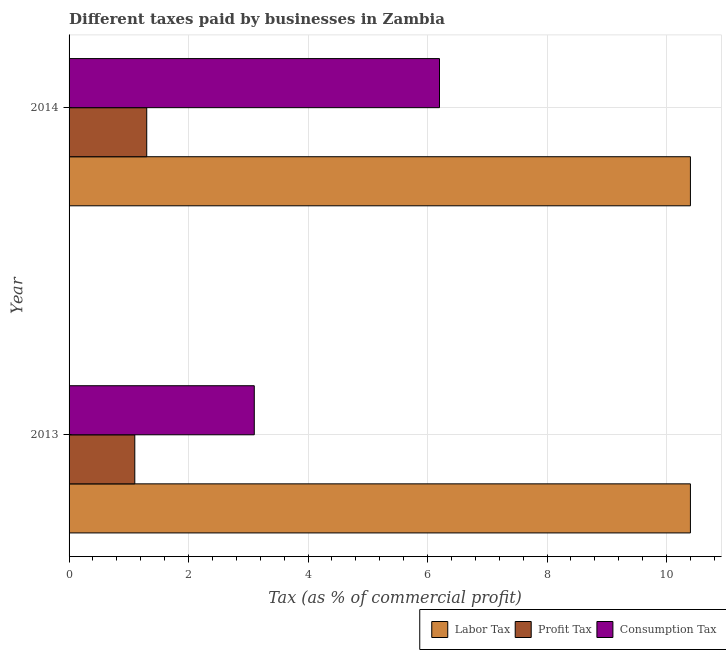How many groups of bars are there?
Offer a very short reply. 2. How many bars are there on the 2nd tick from the bottom?
Provide a succinct answer. 3. What is the label of the 1st group of bars from the top?
Provide a succinct answer. 2014. In how many cases, is the number of bars for a given year not equal to the number of legend labels?
Provide a succinct answer. 0. What is the percentage of profit tax in 2014?
Keep it short and to the point. 1.3. Across all years, what is the maximum percentage of consumption tax?
Ensure brevity in your answer.  6.2. Across all years, what is the minimum percentage of consumption tax?
Your answer should be compact. 3.1. In which year was the percentage of labor tax minimum?
Your answer should be very brief. 2013. What is the difference between the percentage of profit tax in 2013 and the percentage of consumption tax in 2014?
Offer a terse response. -5.1. What is the average percentage of labor tax per year?
Keep it short and to the point. 10.4. In the year 2014, what is the difference between the percentage of profit tax and percentage of consumption tax?
Provide a succinct answer. -4.9. What is the ratio of the percentage of profit tax in 2013 to that in 2014?
Keep it short and to the point. 0.85. Is the percentage of consumption tax in 2013 less than that in 2014?
Make the answer very short. Yes. Is the difference between the percentage of consumption tax in 2013 and 2014 greater than the difference between the percentage of labor tax in 2013 and 2014?
Make the answer very short. No. In how many years, is the percentage of profit tax greater than the average percentage of profit tax taken over all years?
Give a very brief answer. 1. What does the 2nd bar from the top in 2014 represents?
Give a very brief answer. Profit Tax. What does the 1st bar from the bottom in 2013 represents?
Your answer should be compact. Labor Tax. Are all the bars in the graph horizontal?
Offer a very short reply. Yes. What is the difference between two consecutive major ticks on the X-axis?
Your response must be concise. 2. Are the values on the major ticks of X-axis written in scientific E-notation?
Ensure brevity in your answer.  No. Does the graph contain any zero values?
Your answer should be very brief. No. Where does the legend appear in the graph?
Ensure brevity in your answer.  Bottom right. What is the title of the graph?
Offer a very short reply. Different taxes paid by businesses in Zambia. What is the label or title of the X-axis?
Offer a terse response. Tax (as % of commercial profit). What is the Tax (as % of commercial profit) in Labor Tax in 2013?
Ensure brevity in your answer.  10.4. What is the Tax (as % of commercial profit) in Profit Tax in 2013?
Make the answer very short. 1.1. What is the Tax (as % of commercial profit) in Labor Tax in 2014?
Keep it short and to the point. 10.4. Across all years, what is the maximum Tax (as % of commercial profit) of Labor Tax?
Keep it short and to the point. 10.4. Across all years, what is the minimum Tax (as % of commercial profit) in Profit Tax?
Your response must be concise. 1.1. Across all years, what is the minimum Tax (as % of commercial profit) in Consumption Tax?
Ensure brevity in your answer.  3.1. What is the total Tax (as % of commercial profit) of Labor Tax in the graph?
Your response must be concise. 20.8. What is the total Tax (as % of commercial profit) in Profit Tax in the graph?
Your answer should be very brief. 2.4. What is the difference between the Tax (as % of commercial profit) in Labor Tax in 2013 and that in 2014?
Offer a terse response. 0. What is the difference between the Tax (as % of commercial profit) in Consumption Tax in 2013 and that in 2014?
Offer a terse response. -3.1. What is the difference between the Tax (as % of commercial profit) of Labor Tax in 2013 and the Tax (as % of commercial profit) of Consumption Tax in 2014?
Keep it short and to the point. 4.2. What is the average Tax (as % of commercial profit) in Labor Tax per year?
Make the answer very short. 10.4. What is the average Tax (as % of commercial profit) in Profit Tax per year?
Give a very brief answer. 1.2. What is the average Tax (as % of commercial profit) in Consumption Tax per year?
Provide a succinct answer. 4.65. In the year 2013, what is the difference between the Tax (as % of commercial profit) in Labor Tax and Tax (as % of commercial profit) in Profit Tax?
Your response must be concise. 9.3. In the year 2014, what is the difference between the Tax (as % of commercial profit) in Profit Tax and Tax (as % of commercial profit) in Consumption Tax?
Give a very brief answer. -4.9. What is the ratio of the Tax (as % of commercial profit) in Labor Tax in 2013 to that in 2014?
Ensure brevity in your answer.  1. What is the ratio of the Tax (as % of commercial profit) in Profit Tax in 2013 to that in 2014?
Keep it short and to the point. 0.85. What is the ratio of the Tax (as % of commercial profit) in Consumption Tax in 2013 to that in 2014?
Offer a terse response. 0.5. What is the difference between the highest and the second highest Tax (as % of commercial profit) of Consumption Tax?
Give a very brief answer. 3.1. 